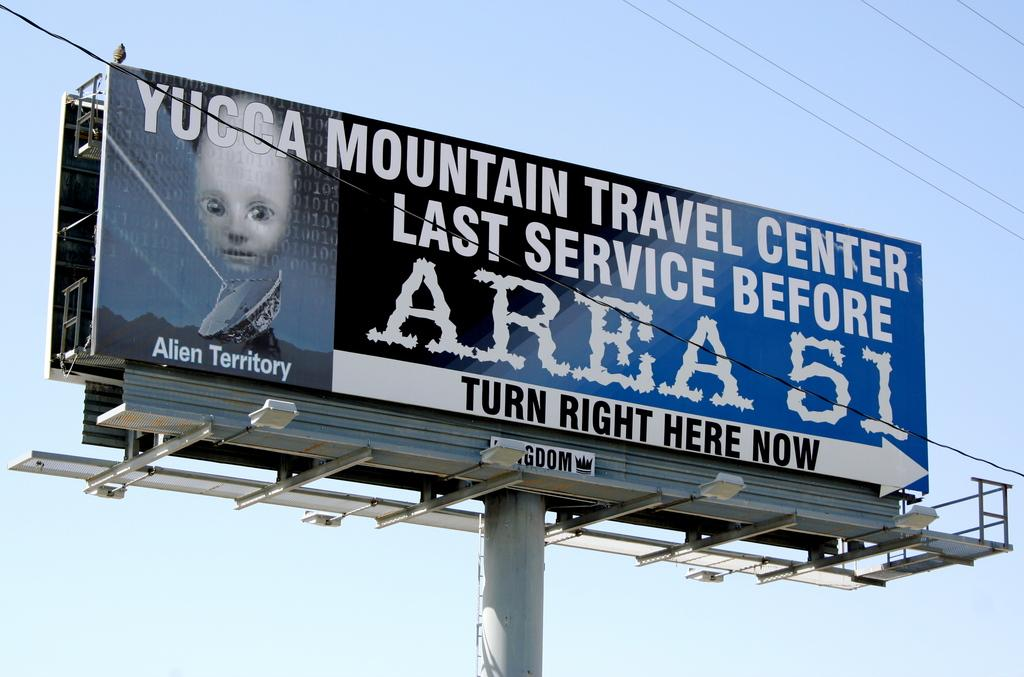<image>
Describe the image concisely. a billboard in the sky reads Yucca Mountain and Area 51 